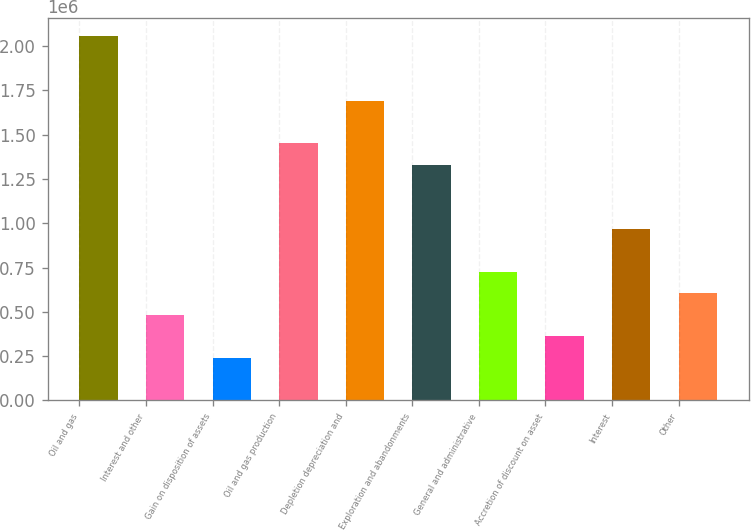Convert chart to OTSL. <chart><loc_0><loc_0><loc_500><loc_500><bar_chart><fcel>Oil and gas<fcel>Interest and other<fcel>Gain on disposition of assets<fcel>Oil and gas production<fcel>Depletion depreciation and<fcel>Exploration and abandonments<fcel>General and administrative<fcel>Accretion of discount on asset<fcel>Interest<fcel>Other<nl><fcel>2.05466e+06<fcel>483449<fcel>241724<fcel>1.45035e+06<fcel>1.69207e+06<fcel>1.32948e+06<fcel>725173<fcel>362586<fcel>966897<fcel>604311<nl></chart> 